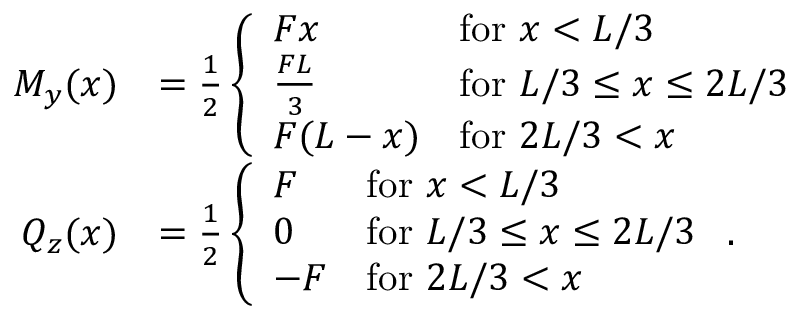Convert formula to latex. <formula><loc_0><loc_0><loc_500><loc_500>\begin{array} { r l } { M _ { y } ( x ) } & { = \frac { 1 } { 2 } \left \{ \begin{array} { l l } { F x } & { f o r x < L / 3 } \\ { \frac { F L } { 3 } } & { f o r L / 3 \leq x \leq 2 L / 3 } \\ { F ( L - x ) } & { f o r 2 L / 3 < x } \end{array} } \\ { Q _ { z } ( x ) } & { = \frac { 1 } { 2 } \left \{ \begin{array} { l l } { F } & { f o r x < L / 3 } \\ { 0 } & { f o r L / 3 \leq x \leq 2 L / 3 } \\ { - F } & { f o r 2 L / 3 < x } \end{array} . } \end{array}</formula> 